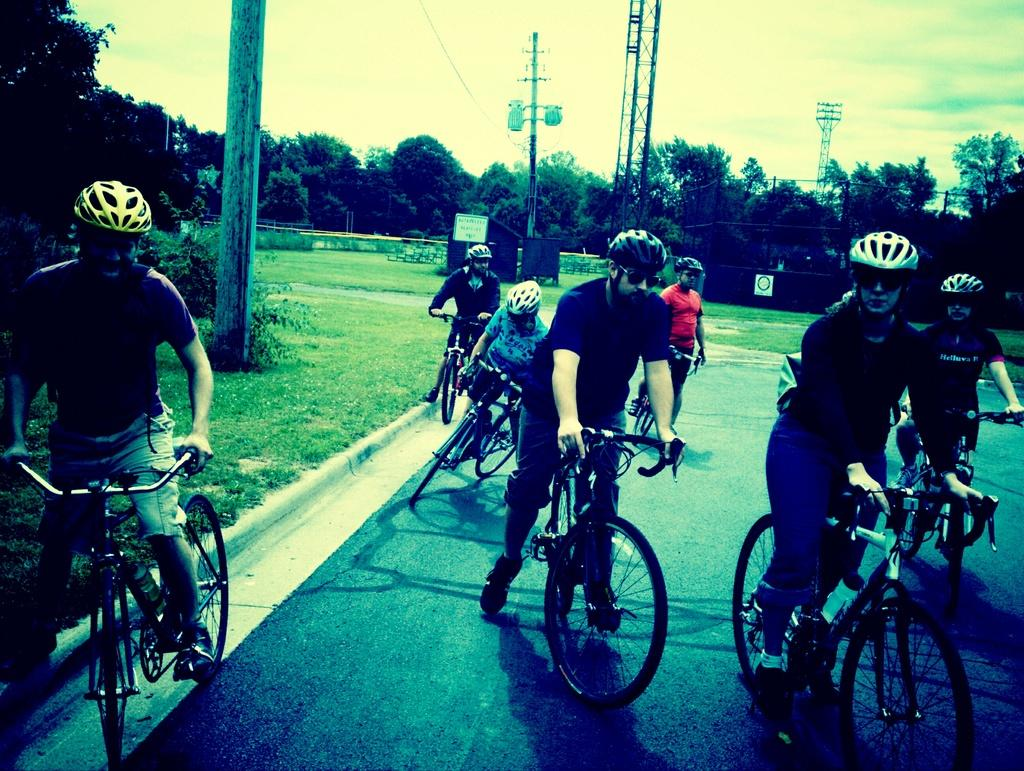What are the people in the image doing? The people in the image are riding bicycles. What can be seen on the left side of the image? There is a pole on the left side of the image. What is visible in the background of the image? There are towers, trees, and the sky visible in the background of the image. What type of cake is being served on the pole in the image? There is no cake present in the image, and the pole is not serving any food. How much honey is dripping from the sky in the image? There is no honey present in the image, and the sky is not dripping any substance. 